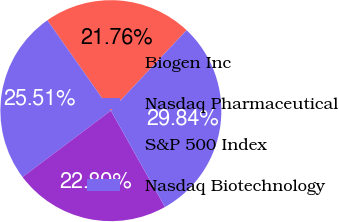<chart> <loc_0><loc_0><loc_500><loc_500><pie_chart><fcel>Biogen Inc<fcel>Nasdaq Pharmaceutical<fcel>S&P 500 Index<fcel>Nasdaq Biotechnology<nl><fcel>21.76%<fcel>25.51%<fcel>22.89%<fcel>29.84%<nl></chart> 